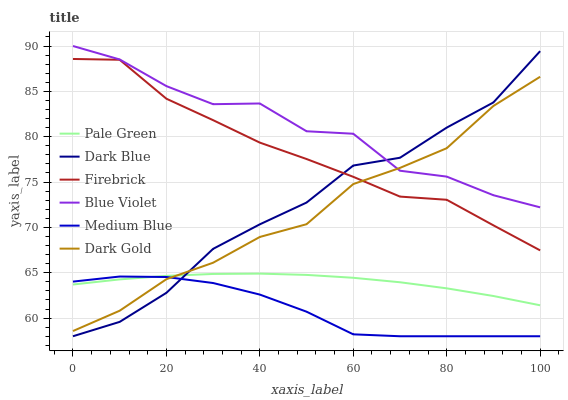Does Medium Blue have the minimum area under the curve?
Answer yes or no. Yes. Does Blue Violet have the maximum area under the curve?
Answer yes or no. Yes. Does Firebrick have the minimum area under the curve?
Answer yes or no. No. Does Firebrick have the maximum area under the curve?
Answer yes or no. No. Is Pale Green the smoothest?
Answer yes or no. Yes. Is Blue Violet the roughest?
Answer yes or no. Yes. Is Firebrick the smoothest?
Answer yes or no. No. Is Firebrick the roughest?
Answer yes or no. No. Does Firebrick have the lowest value?
Answer yes or no. No. Does Firebrick have the highest value?
Answer yes or no. No. Is Pale Green less than Firebrick?
Answer yes or no. Yes. Is Firebrick greater than Pale Green?
Answer yes or no. Yes. Does Pale Green intersect Firebrick?
Answer yes or no. No. 